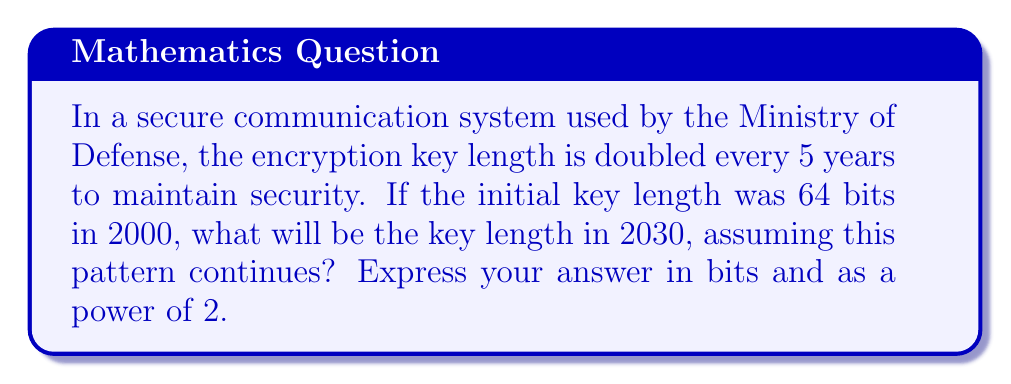Show me your answer to this math problem. Let's approach this step-by-step:

1) First, let's determine how many 5-year periods have passed from 2000 to 2030:
   $\frac{2030 - 2000}{5} = 6$ periods

2) Each period doubles the key length. This means we're multiplying by 2 six times:
   $64 \cdot 2^6$

3) We can simplify this:
   $64 \cdot 2^6 = 2^6 \cdot 2^6 = 2^{12}$

4) To calculate $2^{12}$:
   $2^{12} = 4096$

Therefore, the key length in 2030 will be 4096 bits, which can be expressed as $2^{12}$ bits.
Answer: $2^{12}$ bits or 4096 bits 